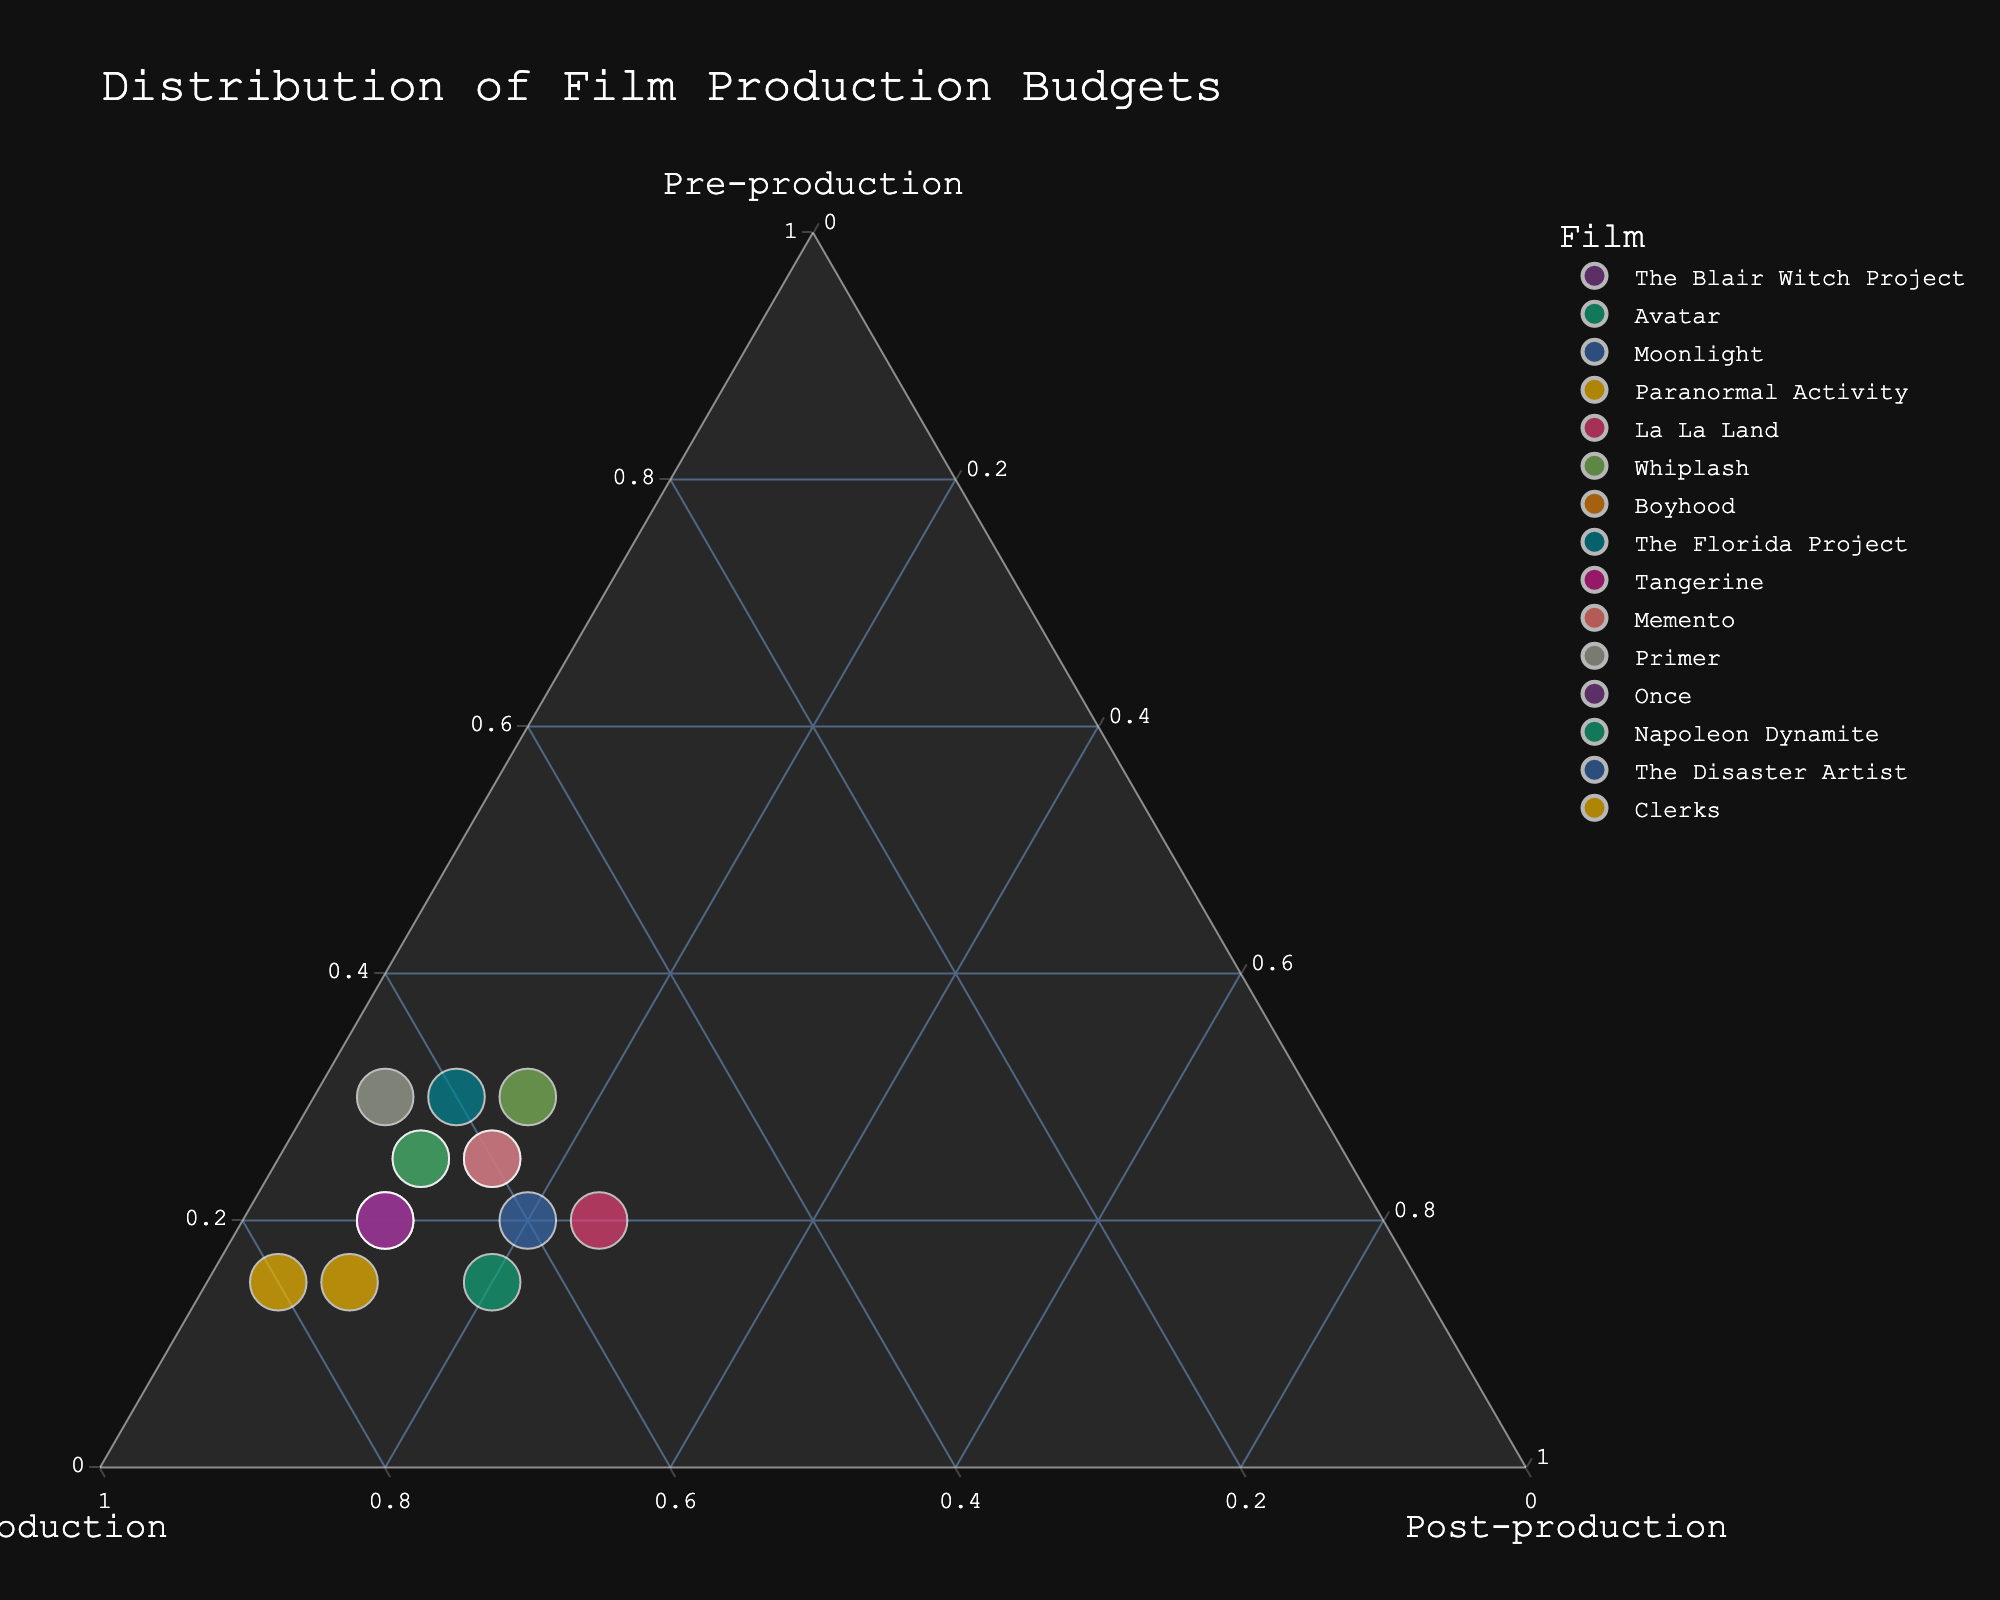What is the title of the plot? The title of the plot is typically placed at the top of the figure, and it summarizes the context of the data being visualized. In the given plot, the title is clear and specifies what the plot represents.
Answer: Distribution of Film Production Budgets How many films are included in the plot? By looking at the number of unique points in the plot, each labeled with a distinct film name, you can count how many films are represented.
Answer: 15 Which film allocated the highest percentage of its budget to pre-production? By identifying the point that is farthest along the axis representing the pre-production percentage, you can find the film with the highest allocation.
Answer: Whiplash Which two films have the same allocation for pre-production? You can check the pre-production percentage values for all points and identify any that are equal to each other.
Answer: The Blair Witch Project and La La Land Which phase did 'Clerks' allocate the least percentage of its budget to? By locating 'Clerks' on the plot and checking its position with respect to the axes, you can determine the phase with the lowest percentage allocation.
Answer: Post-production What is the combined percentage allocation for 'Moonlight' in production and post-production? Add the percentages of production and post-production for 'Moonlight' to calculate the combined allocation.
Answer: 75 Which film has an equal budget allocation for production and post-production? By checking the points where the production and post-production percentages are equal, you can identify the given film.
Answer: La La Land Compare the production budget allocation of 'Primer' and 'Paranormal Activity.' Which has a higher allocation? By comparing the positions of 'Primer' and 'Paranormal Activity' along the production axis, you can identify which one has a higher percentage.
Answer: Paranormal Activity Which film is closest to having an equal distribution among all three phases? The film closest to the center of the ternary plot would have the most balanced allocation across the three phases.
Answer: La La Land Do any films allocate exactly 10% of their budget to post-production? If yes, name them. By examining the points that fall on the 10% post-production mark, you can identify the films that meet this criterion.
Answer: The Blair Witch Project, Paranormal Activity, Boyhood, The Florida Project, Tangerine, Once, Napoleon Dynamite 